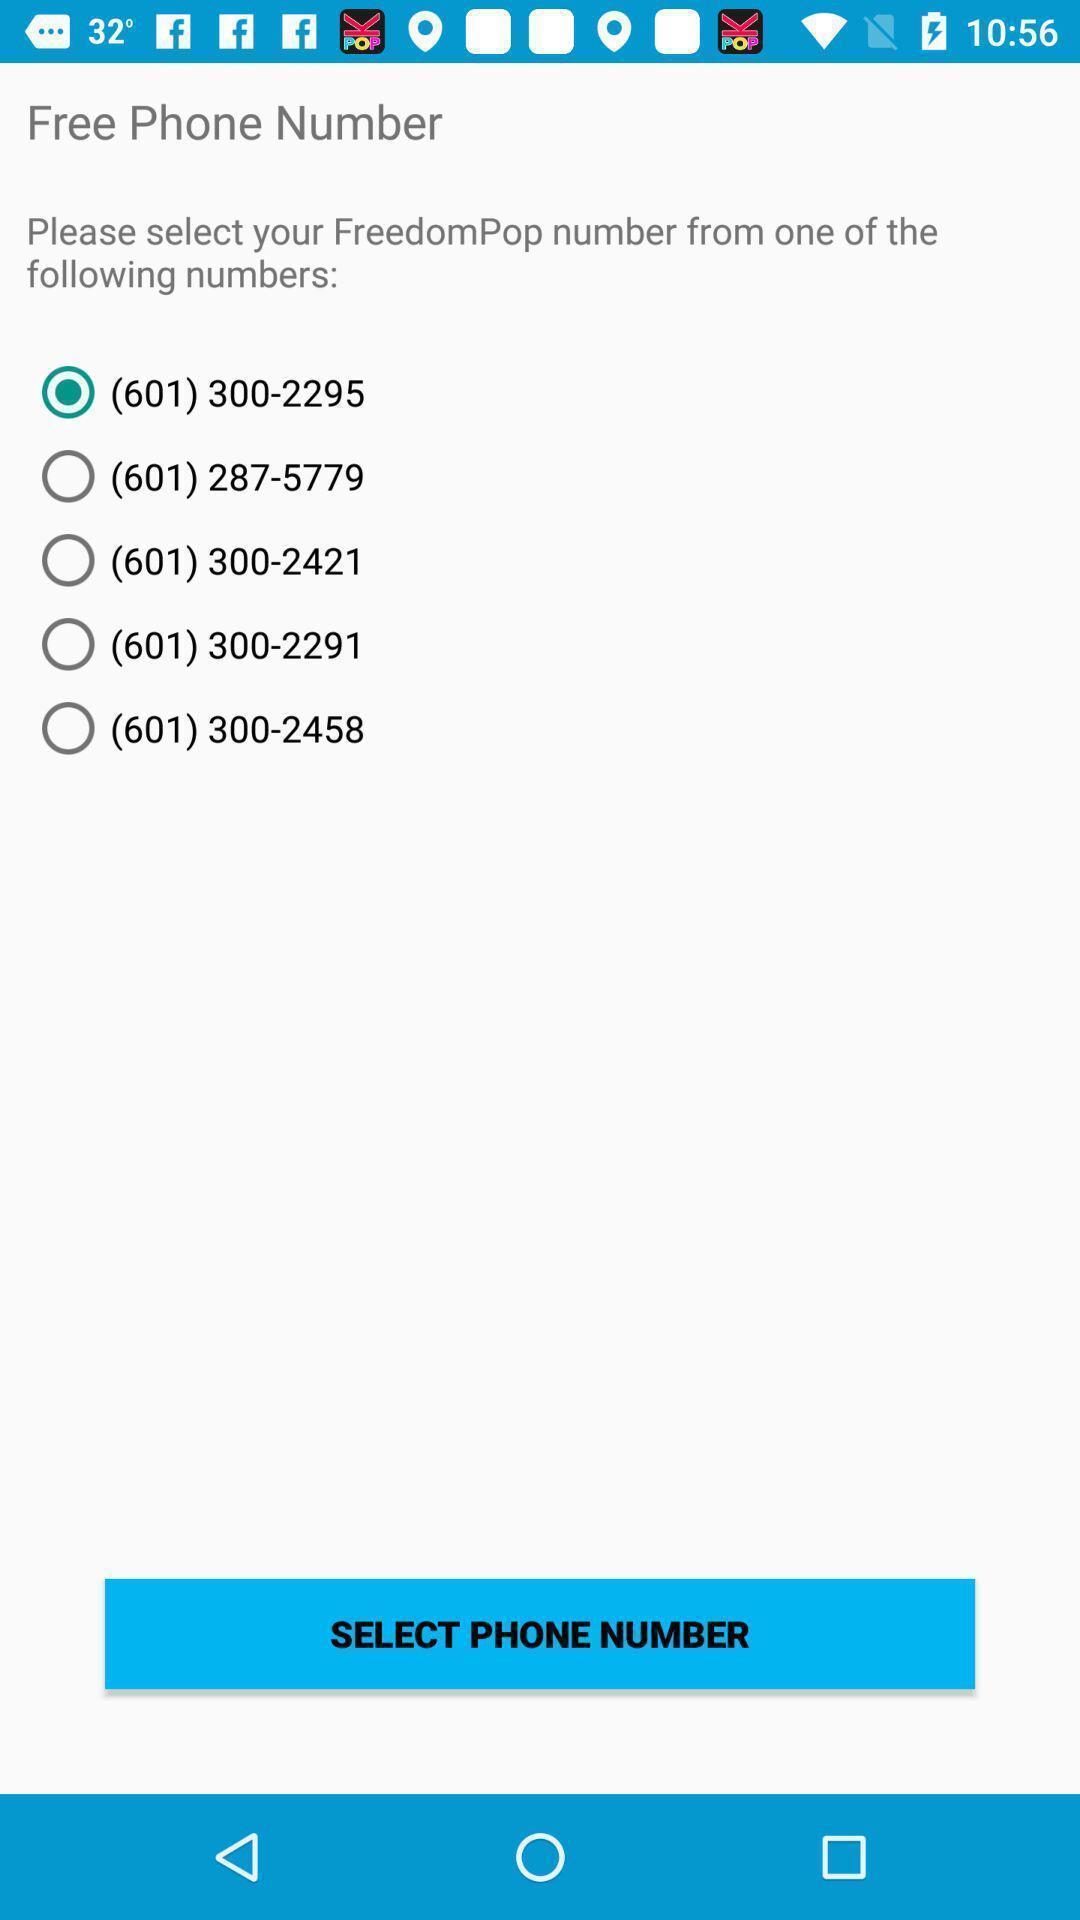Please provide a description for this image. Screen displaying phone numbers to select. 